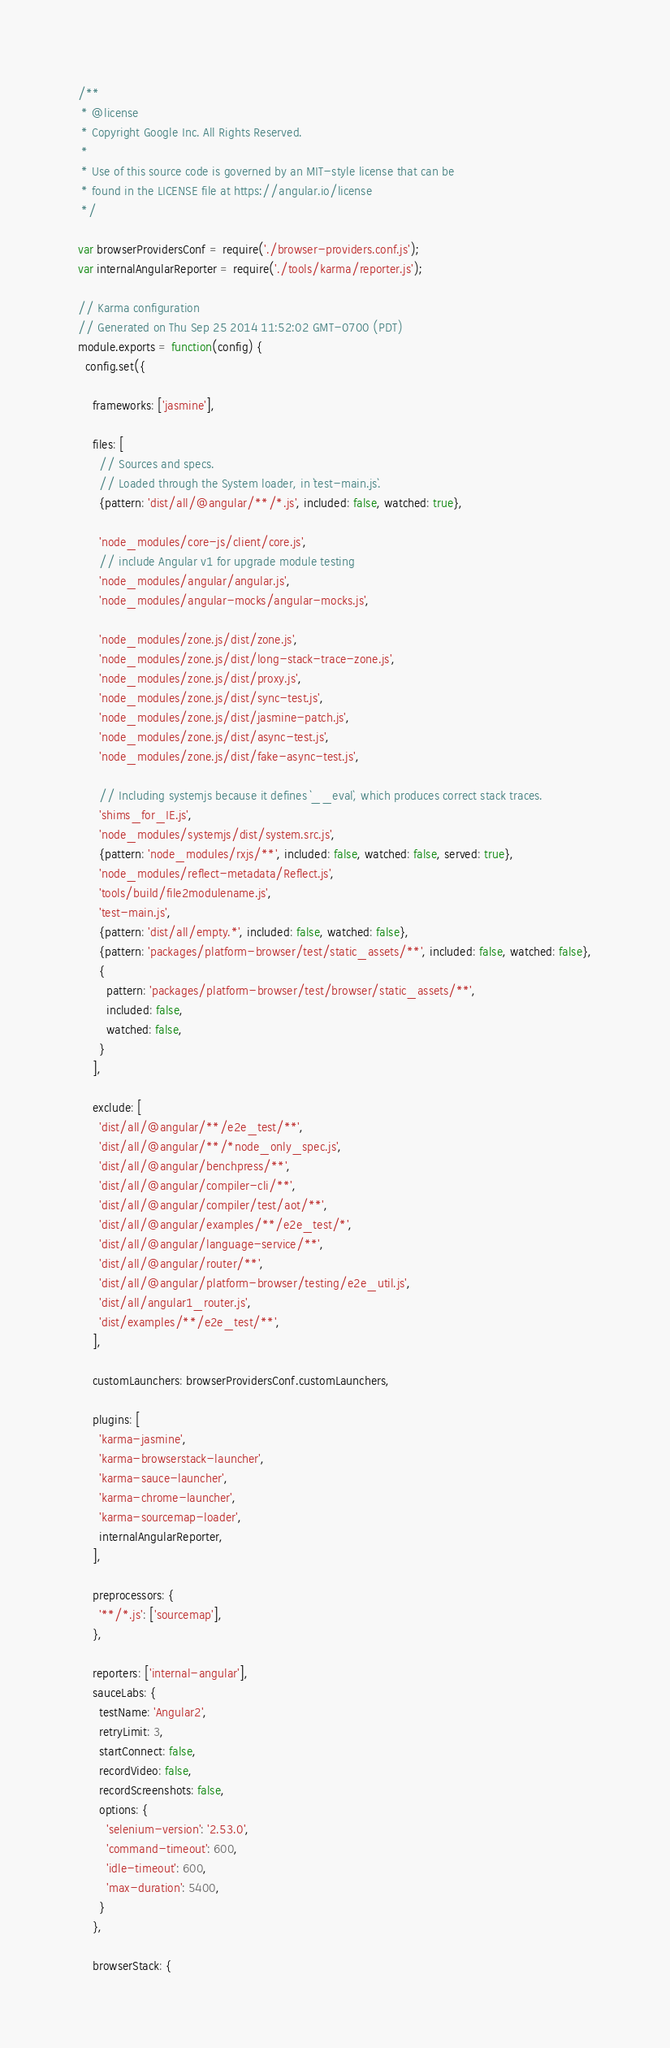Convert code to text. <code><loc_0><loc_0><loc_500><loc_500><_JavaScript_>/**
 * @license
 * Copyright Google Inc. All Rights Reserved.
 *
 * Use of this source code is governed by an MIT-style license that can be
 * found in the LICENSE file at https://angular.io/license
 */

var browserProvidersConf = require('./browser-providers.conf.js');
var internalAngularReporter = require('./tools/karma/reporter.js');

// Karma configuration
// Generated on Thu Sep 25 2014 11:52:02 GMT-0700 (PDT)
module.exports = function(config) {
  config.set({

    frameworks: ['jasmine'],

    files: [
      // Sources and specs.
      // Loaded through the System loader, in `test-main.js`.
      {pattern: 'dist/all/@angular/**/*.js', included: false, watched: true},

      'node_modules/core-js/client/core.js',
      // include Angular v1 for upgrade module testing
      'node_modules/angular/angular.js',
      'node_modules/angular-mocks/angular-mocks.js',

      'node_modules/zone.js/dist/zone.js',
      'node_modules/zone.js/dist/long-stack-trace-zone.js',
      'node_modules/zone.js/dist/proxy.js',
      'node_modules/zone.js/dist/sync-test.js',
      'node_modules/zone.js/dist/jasmine-patch.js',
      'node_modules/zone.js/dist/async-test.js',
      'node_modules/zone.js/dist/fake-async-test.js',

      // Including systemjs because it defines `__eval`, which produces correct stack traces.
      'shims_for_IE.js',
      'node_modules/systemjs/dist/system.src.js',
      {pattern: 'node_modules/rxjs/**', included: false, watched: false, served: true},
      'node_modules/reflect-metadata/Reflect.js',
      'tools/build/file2modulename.js',
      'test-main.js',
      {pattern: 'dist/all/empty.*', included: false, watched: false},
      {pattern: 'packages/platform-browser/test/static_assets/**', included: false, watched: false},
      {
        pattern: 'packages/platform-browser/test/browser/static_assets/**',
        included: false,
        watched: false,
      }
    ],

    exclude: [
      'dist/all/@angular/**/e2e_test/**',
      'dist/all/@angular/**/*node_only_spec.js',
      'dist/all/@angular/benchpress/**',
      'dist/all/@angular/compiler-cli/**',
      'dist/all/@angular/compiler/test/aot/**',
      'dist/all/@angular/examples/**/e2e_test/*',
      'dist/all/@angular/language-service/**',
      'dist/all/@angular/router/**',
      'dist/all/@angular/platform-browser/testing/e2e_util.js',
      'dist/all/angular1_router.js',
      'dist/examples/**/e2e_test/**',
    ],

    customLaunchers: browserProvidersConf.customLaunchers,

    plugins: [
      'karma-jasmine',
      'karma-browserstack-launcher',
      'karma-sauce-launcher',
      'karma-chrome-launcher',
      'karma-sourcemap-loader',
      internalAngularReporter,
    ],

    preprocessors: {
      '**/*.js': ['sourcemap'],
    },

    reporters: ['internal-angular'],
    sauceLabs: {
      testName: 'Angular2',
      retryLimit: 3,
      startConnect: false,
      recordVideo: false,
      recordScreenshots: false,
      options: {
        'selenium-version': '2.53.0',
        'command-timeout': 600,
        'idle-timeout': 600,
        'max-duration': 5400,
      }
    },

    browserStack: {</code> 